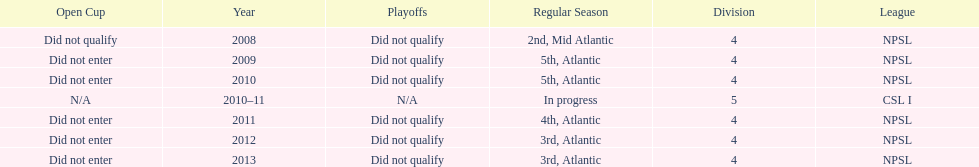What is the lowest place they came in 5th. 